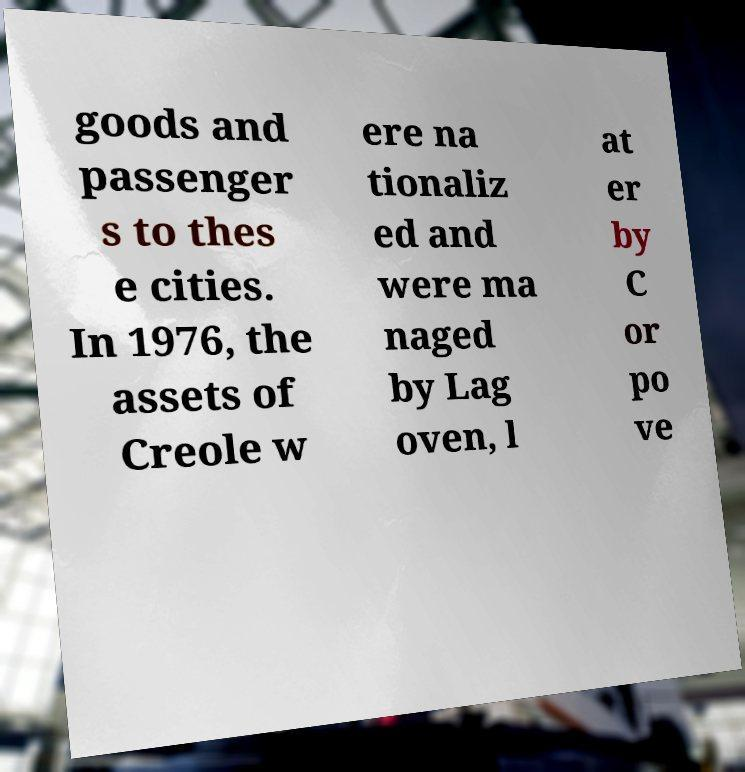Please identify and transcribe the text found in this image. goods and passenger s to thes e cities. In 1976, the assets of Creole w ere na tionaliz ed and were ma naged by Lag oven, l at er by C or po ve 